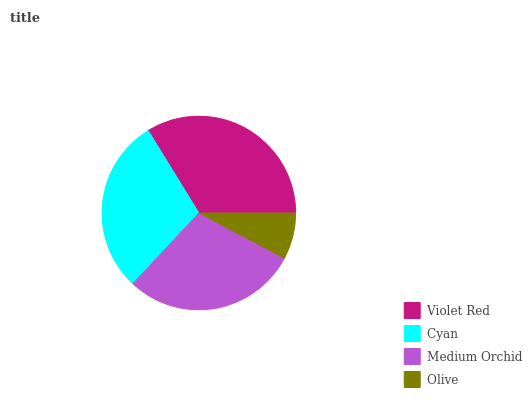Is Olive the minimum?
Answer yes or no. Yes. Is Violet Red the maximum?
Answer yes or no. Yes. Is Cyan the minimum?
Answer yes or no. No. Is Cyan the maximum?
Answer yes or no. No. Is Violet Red greater than Cyan?
Answer yes or no. Yes. Is Cyan less than Violet Red?
Answer yes or no. Yes. Is Cyan greater than Violet Red?
Answer yes or no. No. Is Violet Red less than Cyan?
Answer yes or no. No. Is Cyan the high median?
Answer yes or no. Yes. Is Medium Orchid the low median?
Answer yes or no. Yes. Is Violet Red the high median?
Answer yes or no. No. Is Cyan the low median?
Answer yes or no. No. 